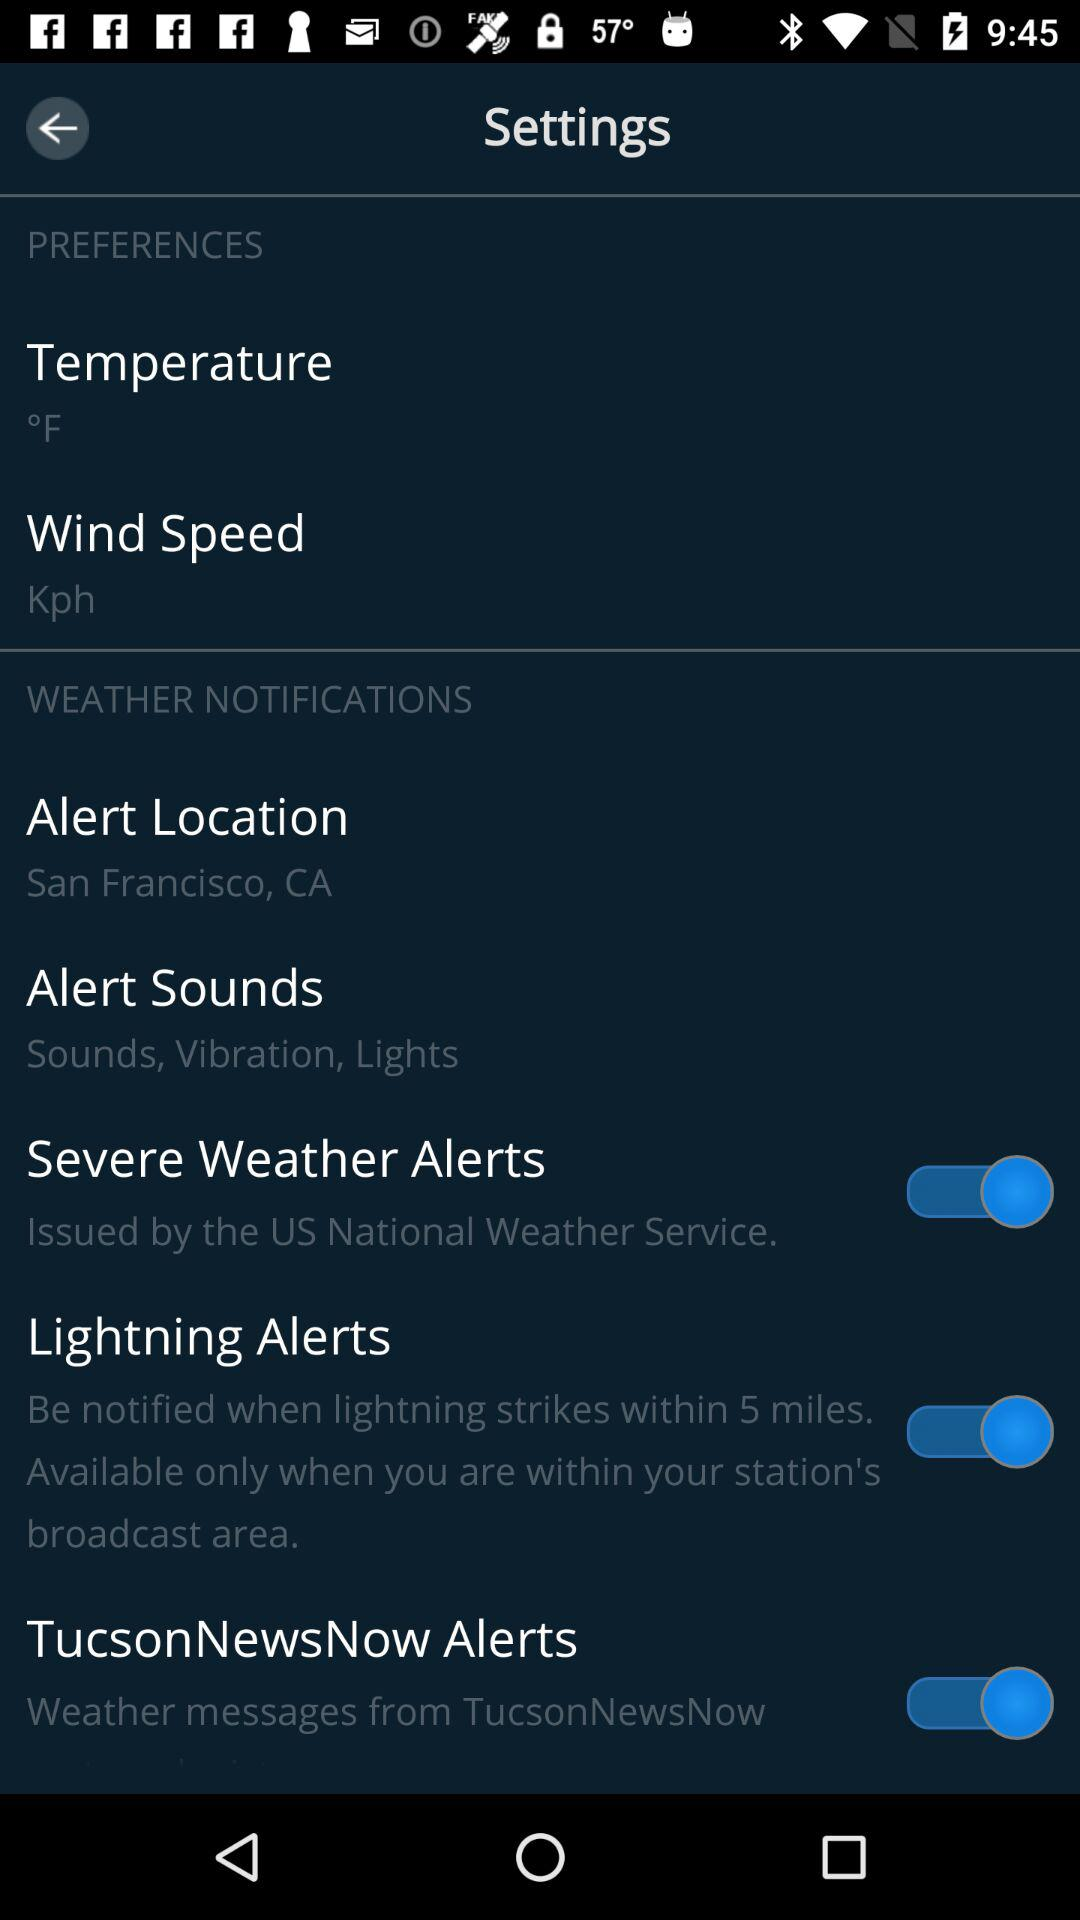What is the status of the "Lightning Alerts"? The status is "on". 